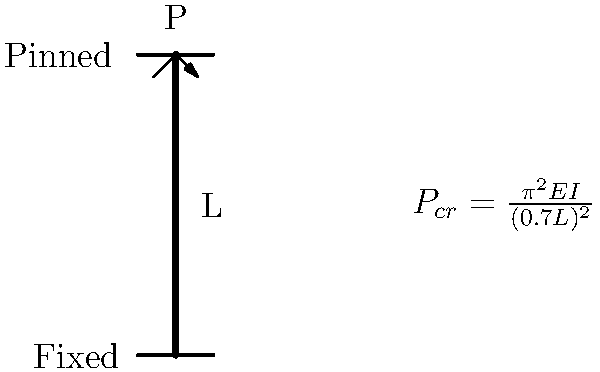As an experienced tournament player coaching children, you understand the importance of strategic thinking and adapting to different scenarios. In structural engineering, columns face various end conditions that affect their critical buckling load. Consider a steel column with one end fixed and the other end pinned, as shown in the diagram. If the column has a length of 4 meters, Young's modulus of 200 GPa, and a moment of inertia of $1.5 \times 10^{-5} m^4$, what is the critical buckling load $P_{cr}$ for this column? Use the provided equation in the diagram. To solve this problem, we'll follow these steps:

1) Identify the given information:
   - Column length, $L = 4$ m
   - Young's modulus, $E = 200$ GPa = $200 \times 10^9$ Pa
   - Moment of inertia, $I = 1.5 \times 10^{-5} m^4$
   - End conditions: Fixed-Pinned

2) Recognize the equation for critical buckling load:
   $P_{cr} = \frac{\pi^2 E I}{(0.7 L)^2}$

3) The factor 0.7 in the denominator accounts for the Fixed-Pinned end condition.

4) Substitute the values into the equation:
   $P_{cr} = \frac{\pi^2 (200 \times 10^9) (1.5 \times 10^{-5})}{(0.7 \times 4)^2}$

5) Simplify:
   $P_{cr} = \frac{9.8696 \times 3 \times 10^6}{7.84}$

6) Calculate the final result:
   $P_{cr} = 3.77 \times 10^6$ N or 3.77 MN

This critical buckling load represents the maximum axial load the column can support before buckling occurs.
Answer: 3.77 MN 